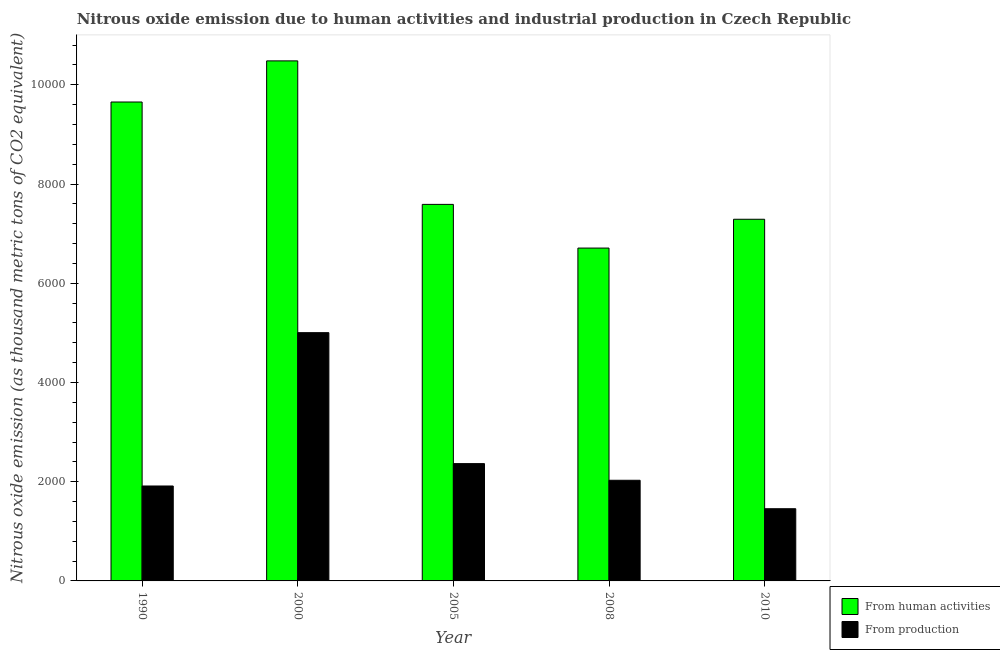How many groups of bars are there?
Keep it short and to the point. 5. What is the label of the 5th group of bars from the left?
Provide a short and direct response. 2010. In how many cases, is the number of bars for a given year not equal to the number of legend labels?
Offer a very short reply. 0. What is the amount of emissions from human activities in 2008?
Your answer should be compact. 6709.7. Across all years, what is the maximum amount of emissions from human activities?
Give a very brief answer. 1.05e+04. Across all years, what is the minimum amount of emissions from human activities?
Give a very brief answer. 6709.7. What is the total amount of emissions from human activities in the graph?
Ensure brevity in your answer.  4.17e+04. What is the difference between the amount of emissions generated from industries in 1990 and that in 2005?
Offer a terse response. -450.9. What is the difference between the amount of emissions from human activities in 2000 and the amount of emissions generated from industries in 2008?
Give a very brief answer. 3773.3. What is the average amount of emissions generated from industries per year?
Ensure brevity in your answer.  2553.36. In the year 2008, what is the difference between the amount of emissions from human activities and amount of emissions generated from industries?
Offer a very short reply. 0. In how many years, is the amount of emissions from human activities greater than 6800 thousand metric tons?
Your answer should be compact. 4. What is the ratio of the amount of emissions from human activities in 1990 to that in 2008?
Make the answer very short. 1.44. What is the difference between the highest and the second highest amount of emissions from human activities?
Provide a short and direct response. 829. What is the difference between the highest and the lowest amount of emissions from human activities?
Offer a terse response. 3773.3. In how many years, is the amount of emissions from human activities greater than the average amount of emissions from human activities taken over all years?
Provide a short and direct response. 2. Is the sum of the amount of emissions generated from industries in 1990 and 2008 greater than the maximum amount of emissions from human activities across all years?
Ensure brevity in your answer.  No. What does the 2nd bar from the left in 2010 represents?
Your answer should be compact. From production. What does the 1st bar from the right in 2005 represents?
Provide a succinct answer. From production. How many years are there in the graph?
Give a very brief answer. 5. Does the graph contain any zero values?
Make the answer very short. No. Does the graph contain grids?
Provide a succinct answer. No. How many legend labels are there?
Provide a short and direct response. 2. What is the title of the graph?
Keep it short and to the point. Nitrous oxide emission due to human activities and industrial production in Czech Republic. Does "Import" appear as one of the legend labels in the graph?
Provide a short and direct response. No. What is the label or title of the Y-axis?
Ensure brevity in your answer.  Nitrous oxide emission (as thousand metric tons of CO2 equivalent). What is the Nitrous oxide emission (as thousand metric tons of CO2 equivalent) of From human activities in 1990?
Your response must be concise. 9654. What is the Nitrous oxide emission (as thousand metric tons of CO2 equivalent) in From production in 1990?
Offer a very short reply. 1913.6. What is the Nitrous oxide emission (as thousand metric tons of CO2 equivalent) in From human activities in 2000?
Your answer should be very brief. 1.05e+04. What is the Nitrous oxide emission (as thousand metric tons of CO2 equivalent) of From production in 2000?
Make the answer very short. 5004.5. What is the Nitrous oxide emission (as thousand metric tons of CO2 equivalent) in From human activities in 2005?
Provide a succinct answer. 7590.3. What is the Nitrous oxide emission (as thousand metric tons of CO2 equivalent) in From production in 2005?
Provide a succinct answer. 2364.5. What is the Nitrous oxide emission (as thousand metric tons of CO2 equivalent) in From human activities in 2008?
Keep it short and to the point. 6709.7. What is the Nitrous oxide emission (as thousand metric tons of CO2 equivalent) of From production in 2008?
Your response must be concise. 2028.8. What is the Nitrous oxide emission (as thousand metric tons of CO2 equivalent) of From human activities in 2010?
Provide a short and direct response. 7290.5. What is the Nitrous oxide emission (as thousand metric tons of CO2 equivalent) in From production in 2010?
Your response must be concise. 1455.4. Across all years, what is the maximum Nitrous oxide emission (as thousand metric tons of CO2 equivalent) in From human activities?
Keep it short and to the point. 1.05e+04. Across all years, what is the maximum Nitrous oxide emission (as thousand metric tons of CO2 equivalent) in From production?
Provide a succinct answer. 5004.5. Across all years, what is the minimum Nitrous oxide emission (as thousand metric tons of CO2 equivalent) of From human activities?
Make the answer very short. 6709.7. Across all years, what is the minimum Nitrous oxide emission (as thousand metric tons of CO2 equivalent) in From production?
Offer a very short reply. 1455.4. What is the total Nitrous oxide emission (as thousand metric tons of CO2 equivalent) in From human activities in the graph?
Offer a terse response. 4.17e+04. What is the total Nitrous oxide emission (as thousand metric tons of CO2 equivalent) of From production in the graph?
Keep it short and to the point. 1.28e+04. What is the difference between the Nitrous oxide emission (as thousand metric tons of CO2 equivalent) in From human activities in 1990 and that in 2000?
Your response must be concise. -829. What is the difference between the Nitrous oxide emission (as thousand metric tons of CO2 equivalent) in From production in 1990 and that in 2000?
Make the answer very short. -3090.9. What is the difference between the Nitrous oxide emission (as thousand metric tons of CO2 equivalent) of From human activities in 1990 and that in 2005?
Give a very brief answer. 2063.7. What is the difference between the Nitrous oxide emission (as thousand metric tons of CO2 equivalent) of From production in 1990 and that in 2005?
Provide a short and direct response. -450.9. What is the difference between the Nitrous oxide emission (as thousand metric tons of CO2 equivalent) in From human activities in 1990 and that in 2008?
Ensure brevity in your answer.  2944.3. What is the difference between the Nitrous oxide emission (as thousand metric tons of CO2 equivalent) of From production in 1990 and that in 2008?
Your answer should be very brief. -115.2. What is the difference between the Nitrous oxide emission (as thousand metric tons of CO2 equivalent) of From human activities in 1990 and that in 2010?
Keep it short and to the point. 2363.5. What is the difference between the Nitrous oxide emission (as thousand metric tons of CO2 equivalent) of From production in 1990 and that in 2010?
Your answer should be compact. 458.2. What is the difference between the Nitrous oxide emission (as thousand metric tons of CO2 equivalent) in From human activities in 2000 and that in 2005?
Offer a terse response. 2892.7. What is the difference between the Nitrous oxide emission (as thousand metric tons of CO2 equivalent) in From production in 2000 and that in 2005?
Offer a terse response. 2640. What is the difference between the Nitrous oxide emission (as thousand metric tons of CO2 equivalent) in From human activities in 2000 and that in 2008?
Offer a very short reply. 3773.3. What is the difference between the Nitrous oxide emission (as thousand metric tons of CO2 equivalent) of From production in 2000 and that in 2008?
Offer a terse response. 2975.7. What is the difference between the Nitrous oxide emission (as thousand metric tons of CO2 equivalent) in From human activities in 2000 and that in 2010?
Keep it short and to the point. 3192.5. What is the difference between the Nitrous oxide emission (as thousand metric tons of CO2 equivalent) in From production in 2000 and that in 2010?
Keep it short and to the point. 3549.1. What is the difference between the Nitrous oxide emission (as thousand metric tons of CO2 equivalent) in From human activities in 2005 and that in 2008?
Provide a short and direct response. 880.6. What is the difference between the Nitrous oxide emission (as thousand metric tons of CO2 equivalent) in From production in 2005 and that in 2008?
Keep it short and to the point. 335.7. What is the difference between the Nitrous oxide emission (as thousand metric tons of CO2 equivalent) in From human activities in 2005 and that in 2010?
Keep it short and to the point. 299.8. What is the difference between the Nitrous oxide emission (as thousand metric tons of CO2 equivalent) of From production in 2005 and that in 2010?
Provide a short and direct response. 909.1. What is the difference between the Nitrous oxide emission (as thousand metric tons of CO2 equivalent) of From human activities in 2008 and that in 2010?
Your answer should be compact. -580.8. What is the difference between the Nitrous oxide emission (as thousand metric tons of CO2 equivalent) in From production in 2008 and that in 2010?
Offer a very short reply. 573.4. What is the difference between the Nitrous oxide emission (as thousand metric tons of CO2 equivalent) in From human activities in 1990 and the Nitrous oxide emission (as thousand metric tons of CO2 equivalent) in From production in 2000?
Make the answer very short. 4649.5. What is the difference between the Nitrous oxide emission (as thousand metric tons of CO2 equivalent) of From human activities in 1990 and the Nitrous oxide emission (as thousand metric tons of CO2 equivalent) of From production in 2005?
Give a very brief answer. 7289.5. What is the difference between the Nitrous oxide emission (as thousand metric tons of CO2 equivalent) of From human activities in 1990 and the Nitrous oxide emission (as thousand metric tons of CO2 equivalent) of From production in 2008?
Keep it short and to the point. 7625.2. What is the difference between the Nitrous oxide emission (as thousand metric tons of CO2 equivalent) of From human activities in 1990 and the Nitrous oxide emission (as thousand metric tons of CO2 equivalent) of From production in 2010?
Provide a succinct answer. 8198.6. What is the difference between the Nitrous oxide emission (as thousand metric tons of CO2 equivalent) in From human activities in 2000 and the Nitrous oxide emission (as thousand metric tons of CO2 equivalent) in From production in 2005?
Offer a very short reply. 8118.5. What is the difference between the Nitrous oxide emission (as thousand metric tons of CO2 equivalent) of From human activities in 2000 and the Nitrous oxide emission (as thousand metric tons of CO2 equivalent) of From production in 2008?
Offer a very short reply. 8454.2. What is the difference between the Nitrous oxide emission (as thousand metric tons of CO2 equivalent) in From human activities in 2000 and the Nitrous oxide emission (as thousand metric tons of CO2 equivalent) in From production in 2010?
Provide a succinct answer. 9027.6. What is the difference between the Nitrous oxide emission (as thousand metric tons of CO2 equivalent) of From human activities in 2005 and the Nitrous oxide emission (as thousand metric tons of CO2 equivalent) of From production in 2008?
Offer a very short reply. 5561.5. What is the difference between the Nitrous oxide emission (as thousand metric tons of CO2 equivalent) in From human activities in 2005 and the Nitrous oxide emission (as thousand metric tons of CO2 equivalent) in From production in 2010?
Your response must be concise. 6134.9. What is the difference between the Nitrous oxide emission (as thousand metric tons of CO2 equivalent) of From human activities in 2008 and the Nitrous oxide emission (as thousand metric tons of CO2 equivalent) of From production in 2010?
Ensure brevity in your answer.  5254.3. What is the average Nitrous oxide emission (as thousand metric tons of CO2 equivalent) of From human activities per year?
Provide a short and direct response. 8345.5. What is the average Nitrous oxide emission (as thousand metric tons of CO2 equivalent) in From production per year?
Your answer should be very brief. 2553.36. In the year 1990, what is the difference between the Nitrous oxide emission (as thousand metric tons of CO2 equivalent) in From human activities and Nitrous oxide emission (as thousand metric tons of CO2 equivalent) in From production?
Offer a very short reply. 7740.4. In the year 2000, what is the difference between the Nitrous oxide emission (as thousand metric tons of CO2 equivalent) in From human activities and Nitrous oxide emission (as thousand metric tons of CO2 equivalent) in From production?
Provide a succinct answer. 5478.5. In the year 2005, what is the difference between the Nitrous oxide emission (as thousand metric tons of CO2 equivalent) of From human activities and Nitrous oxide emission (as thousand metric tons of CO2 equivalent) of From production?
Your answer should be very brief. 5225.8. In the year 2008, what is the difference between the Nitrous oxide emission (as thousand metric tons of CO2 equivalent) in From human activities and Nitrous oxide emission (as thousand metric tons of CO2 equivalent) in From production?
Your answer should be compact. 4680.9. In the year 2010, what is the difference between the Nitrous oxide emission (as thousand metric tons of CO2 equivalent) in From human activities and Nitrous oxide emission (as thousand metric tons of CO2 equivalent) in From production?
Make the answer very short. 5835.1. What is the ratio of the Nitrous oxide emission (as thousand metric tons of CO2 equivalent) of From human activities in 1990 to that in 2000?
Ensure brevity in your answer.  0.92. What is the ratio of the Nitrous oxide emission (as thousand metric tons of CO2 equivalent) of From production in 1990 to that in 2000?
Give a very brief answer. 0.38. What is the ratio of the Nitrous oxide emission (as thousand metric tons of CO2 equivalent) in From human activities in 1990 to that in 2005?
Ensure brevity in your answer.  1.27. What is the ratio of the Nitrous oxide emission (as thousand metric tons of CO2 equivalent) of From production in 1990 to that in 2005?
Offer a very short reply. 0.81. What is the ratio of the Nitrous oxide emission (as thousand metric tons of CO2 equivalent) of From human activities in 1990 to that in 2008?
Your answer should be very brief. 1.44. What is the ratio of the Nitrous oxide emission (as thousand metric tons of CO2 equivalent) of From production in 1990 to that in 2008?
Offer a terse response. 0.94. What is the ratio of the Nitrous oxide emission (as thousand metric tons of CO2 equivalent) of From human activities in 1990 to that in 2010?
Keep it short and to the point. 1.32. What is the ratio of the Nitrous oxide emission (as thousand metric tons of CO2 equivalent) of From production in 1990 to that in 2010?
Your answer should be very brief. 1.31. What is the ratio of the Nitrous oxide emission (as thousand metric tons of CO2 equivalent) of From human activities in 2000 to that in 2005?
Your answer should be very brief. 1.38. What is the ratio of the Nitrous oxide emission (as thousand metric tons of CO2 equivalent) in From production in 2000 to that in 2005?
Offer a terse response. 2.12. What is the ratio of the Nitrous oxide emission (as thousand metric tons of CO2 equivalent) in From human activities in 2000 to that in 2008?
Your response must be concise. 1.56. What is the ratio of the Nitrous oxide emission (as thousand metric tons of CO2 equivalent) of From production in 2000 to that in 2008?
Keep it short and to the point. 2.47. What is the ratio of the Nitrous oxide emission (as thousand metric tons of CO2 equivalent) in From human activities in 2000 to that in 2010?
Provide a succinct answer. 1.44. What is the ratio of the Nitrous oxide emission (as thousand metric tons of CO2 equivalent) in From production in 2000 to that in 2010?
Give a very brief answer. 3.44. What is the ratio of the Nitrous oxide emission (as thousand metric tons of CO2 equivalent) in From human activities in 2005 to that in 2008?
Ensure brevity in your answer.  1.13. What is the ratio of the Nitrous oxide emission (as thousand metric tons of CO2 equivalent) of From production in 2005 to that in 2008?
Ensure brevity in your answer.  1.17. What is the ratio of the Nitrous oxide emission (as thousand metric tons of CO2 equivalent) in From human activities in 2005 to that in 2010?
Ensure brevity in your answer.  1.04. What is the ratio of the Nitrous oxide emission (as thousand metric tons of CO2 equivalent) of From production in 2005 to that in 2010?
Provide a short and direct response. 1.62. What is the ratio of the Nitrous oxide emission (as thousand metric tons of CO2 equivalent) in From human activities in 2008 to that in 2010?
Give a very brief answer. 0.92. What is the ratio of the Nitrous oxide emission (as thousand metric tons of CO2 equivalent) in From production in 2008 to that in 2010?
Make the answer very short. 1.39. What is the difference between the highest and the second highest Nitrous oxide emission (as thousand metric tons of CO2 equivalent) of From human activities?
Offer a very short reply. 829. What is the difference between the highest and the second highest Nitrous oxide emission (as thousand metric tons of CO2 equivalent) of From production?
Make the answer very short. 2640. What is the difference between the highest and the lowest Nitrous oxide emission (as thousand metric tons of CO2 equivalent) in From human activities?
Your answer should be compact. 3773.3. What is the difference between the highest and the lowest Nitrous oxide emission (as thousand metric tons of CO2 equivalent) in From production?
Offer a terse response. 3549.1. 